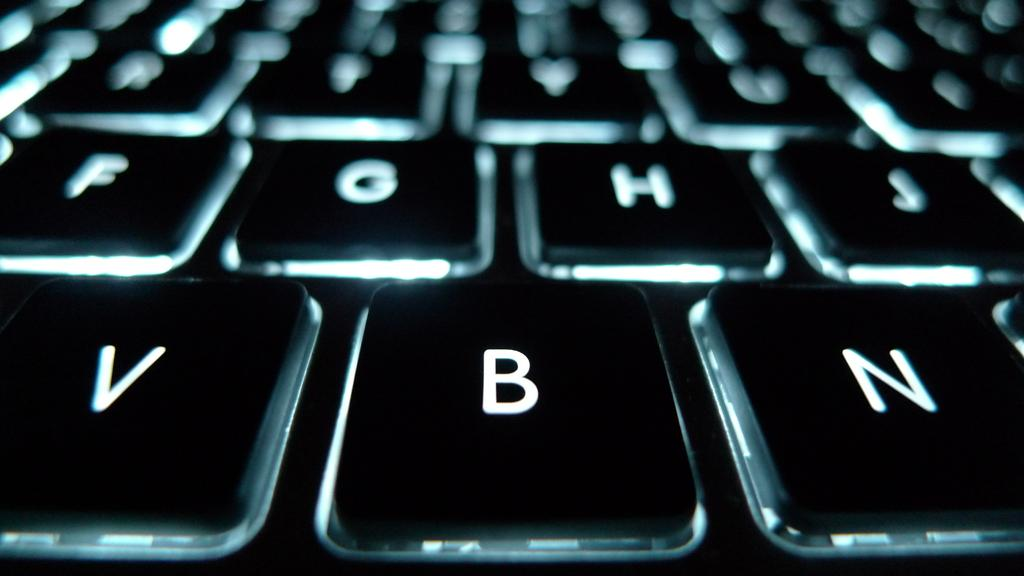<image>
Render a clear and concise summary of the photo. Lit up keyboard with the B key between the V and N key. 